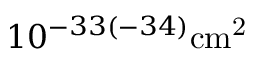<formula> <loc_0><loc_0><loc_500><loc_500>1 0 ^ { - 3 3 ( - 3 4 ) } { c m } ^ { 2 }</formula> 